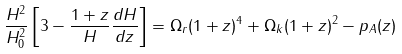<formula> <loc_0><loc_0><loc_500><loc_500>\frac { H ^ { 2 } } { H _ { 0 } ^ { 2 } } \left [ 3 - \frac { 1 + z } { H } \frac { d H } { d z } \right ] = \Omega _ { r } ( 1 + z ) ^ { 4 } + \Omega _ { k } ( 1 + z ) ^ { 2 } - p _ { A } ( z )</formula> 